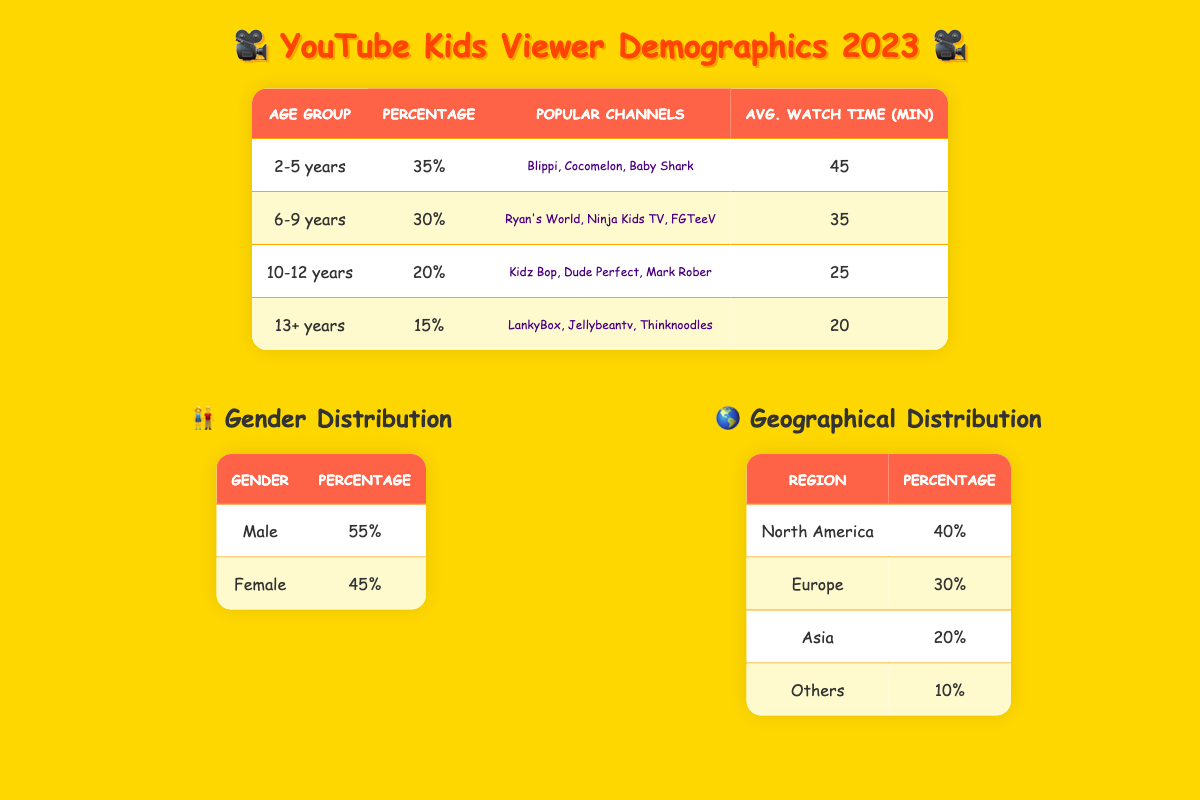What percentage of viewers are aged 2-5 years? According to the table, the demographic data shows that the percentage of viewers aged 2-5 years is 35%.
Answer: 35% Which age group has the highest average watch time? By reviewing the average watch times in the table, the age group 2-5 years has the highest average watch time of 45 minutes.
Answer: 2-5 years What is the total percentage of viewers aged 10 years and older? To find the total percentage of viewers aged 10 years and older, we sum the percentages of the age groups 10-12 years (20%) and 13+ years (15%). Thus, 20 + 15 = 35%.
Answer: 35% Is the viewer demographic more male than female? The table indicates that 55% of viewers are male, while 45% are female, confirming that there are more male viewers than female.
Answer: Yes How many popular channels are listed for the age group 6-9 years? The table lists three popular channels for the age group 6-9 years: Ryan's World, Ninja Kids TV, and FGTeeV.
Answer: 3 What is the average watch time for female viewers? The table does not provide specific average watch time data for female viewers but indicates the overall trends in average watch times by age group. Thus, average watch time cannot be calculated directly for females.
Answer: Not available Which region has the smallest percentage of viewers? By examining the geographical distribution data, the region with the smallest percentage of viewers is "Others" at 10%.
Answer: Others What is the average percentage of viewers in Europe and Asia combined? To calculate the average percentage of viewers in Europe (30%) and Asia (20%), we add their percentages: 30 + 20 = 50%, and then divide by 2. Hence, 50/2 = 25%.
Answer: 25% What percentage of viewers aged 6-12 years prefer Kidz Bop over Ryan's World? To answer this, we look at the age groups: 6-9 years drop down is 30% for Ryan's World and 20% for 10-12 years with Kidz Bop. Thus, the percentage is 20/30 = 66.67% preferring Kidz Bop.
Answer: 66.67% 